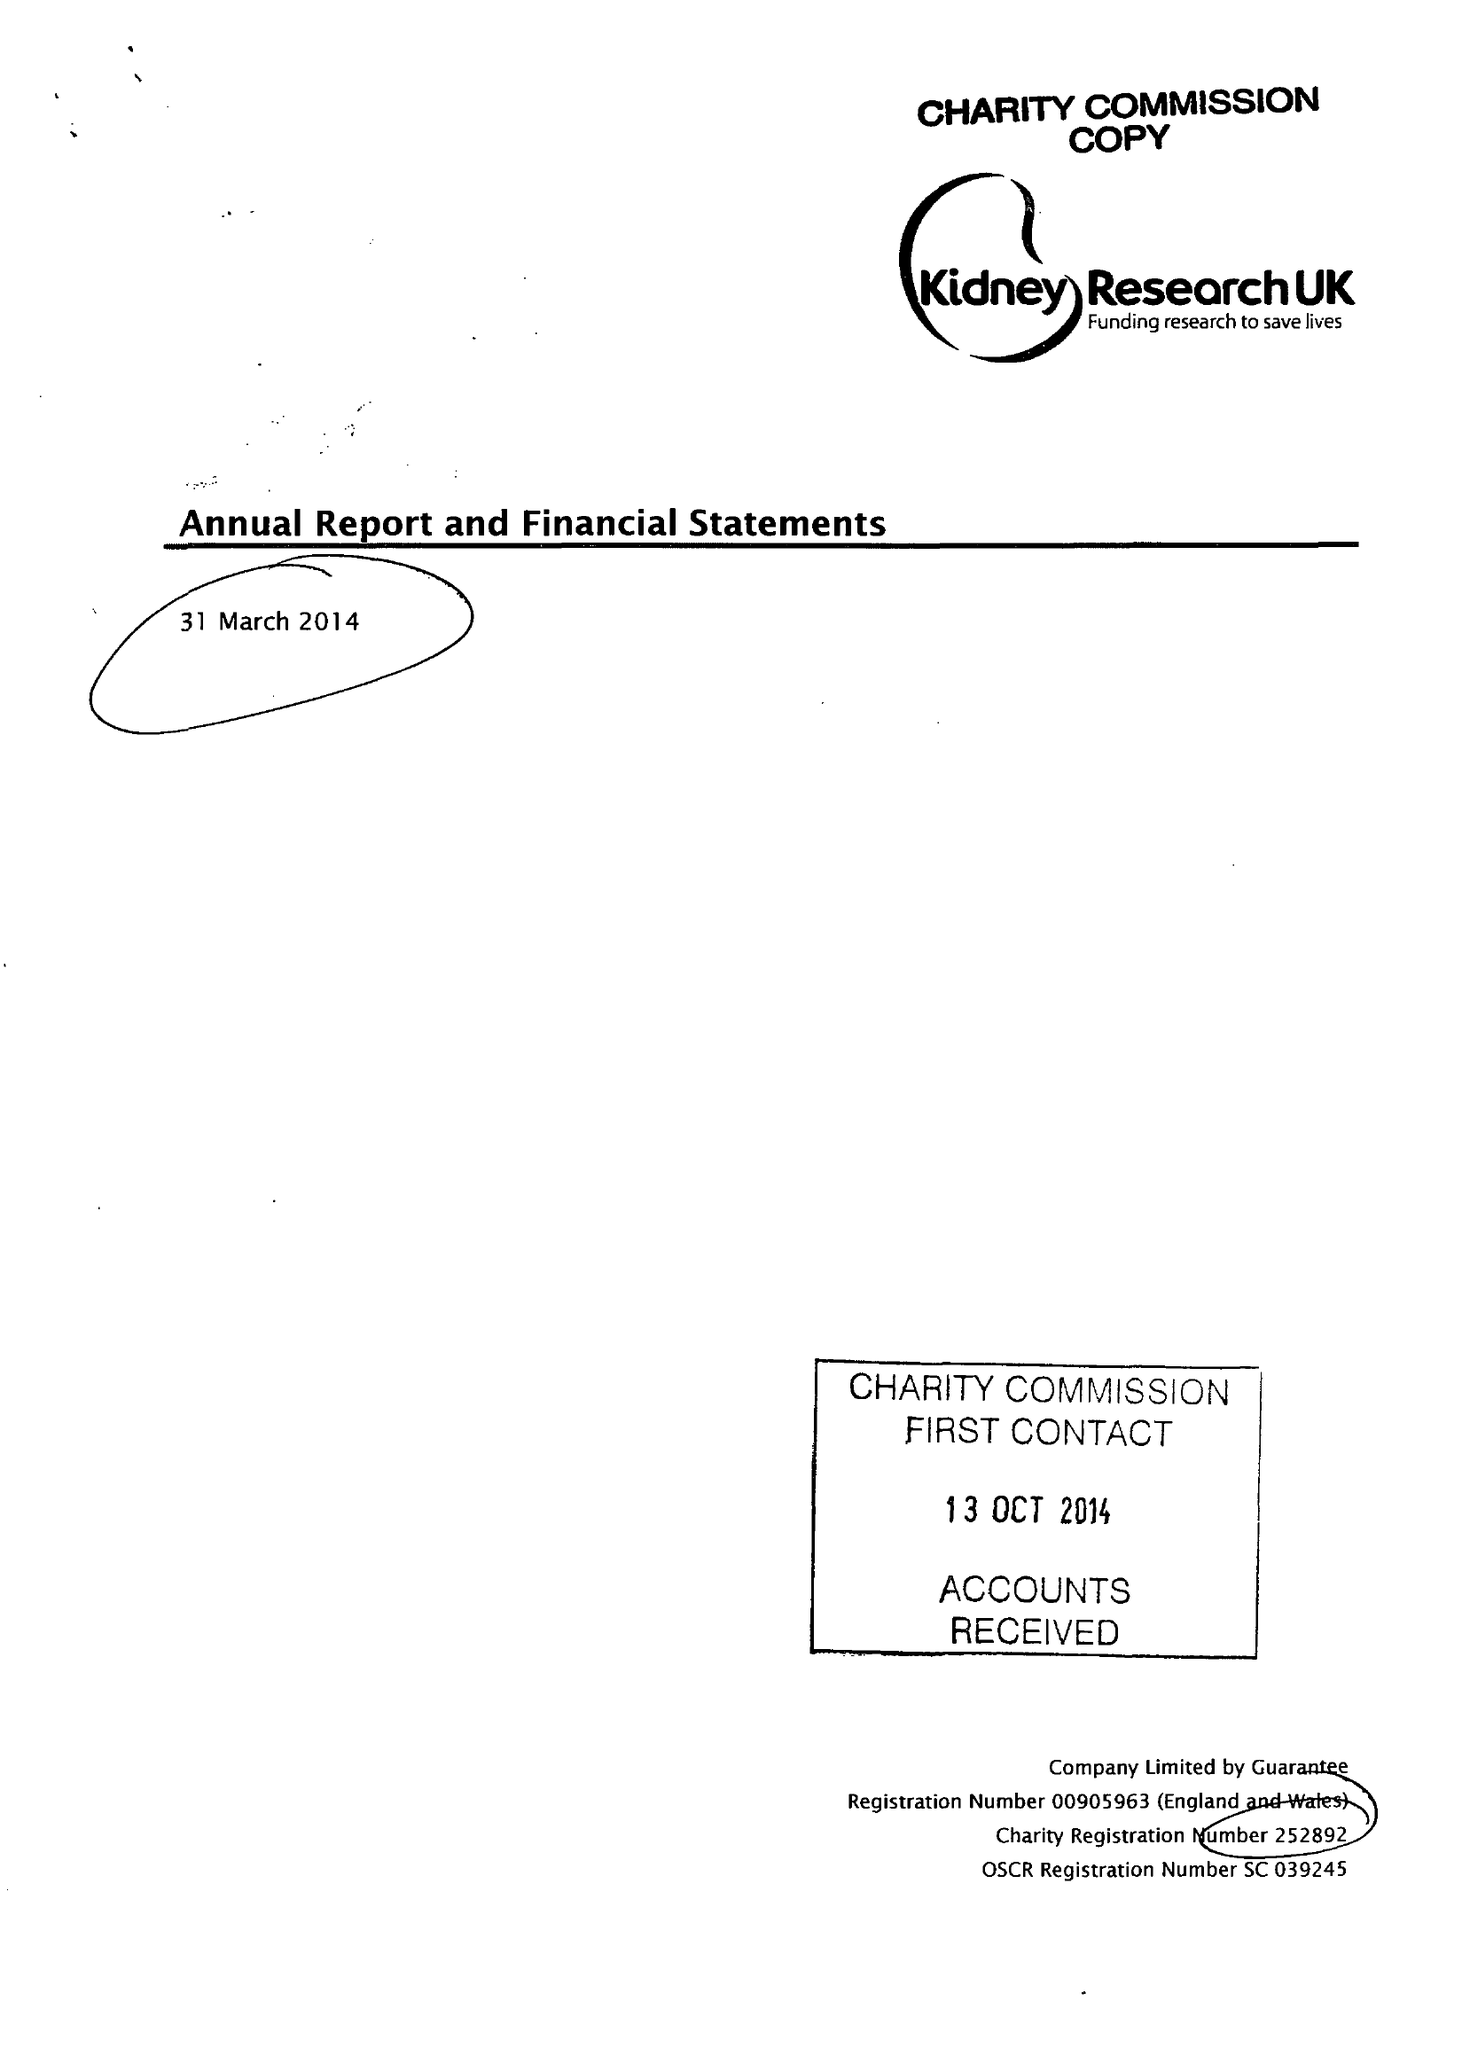What is the value for the charity_name?
Answer the question using a single word or phrase. Kidney Research Uk 